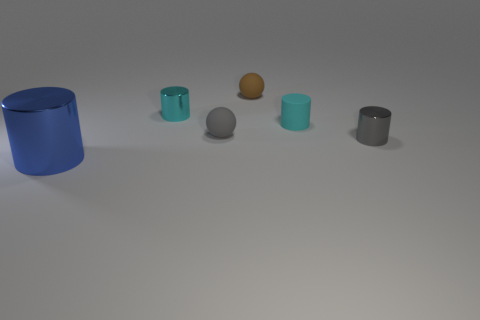Is there another blue shiny object of the same shape as the blue object? After carefully examining the image, there does not appear to be another blue shiny object with the identical shape as the prominent blue cylinder present. 